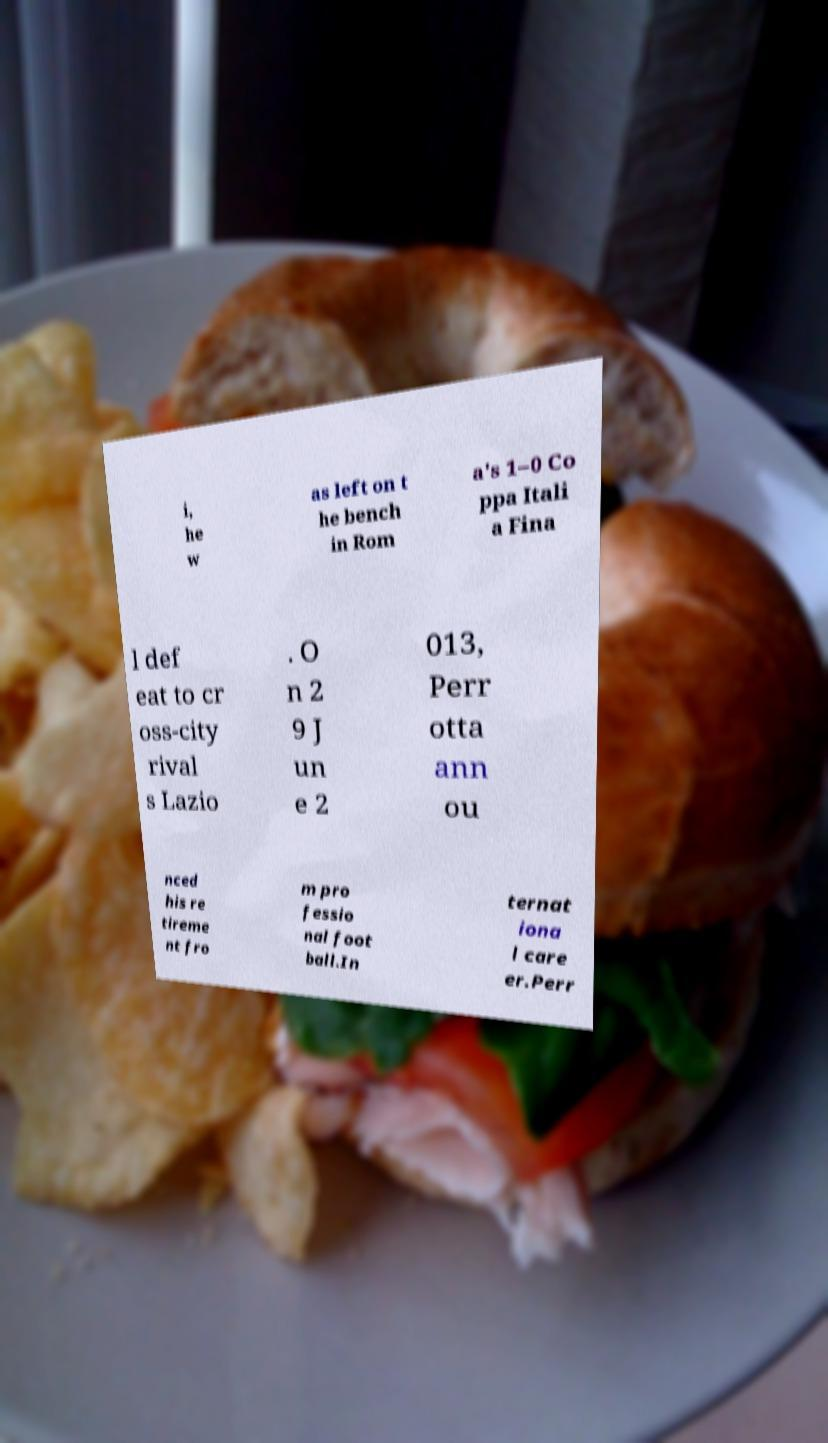There's text embedded in this image that I need extracted. Can you transcribe it verbatim? i, he w as left on t he bench in Rom a's 1–0 Co ppa Itali a Fina l def eat to cr oss-city rival s Lazio . O n 2 9 J un e 2 013, Perr otta ann ou nced his re tireme nt fro m pro fessio nal foot ball.In ternat iona l care er.Perr 